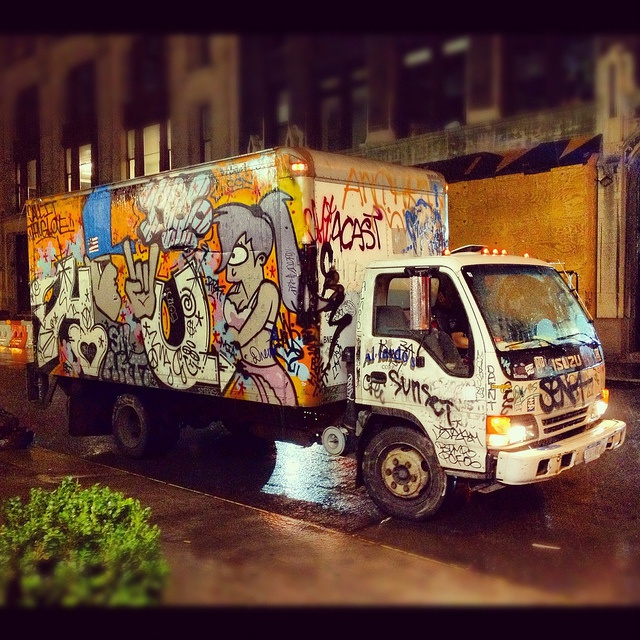Describe the objects in this image and their specific colors. I can see a truck in black, tan, and maroon tones in this image. 